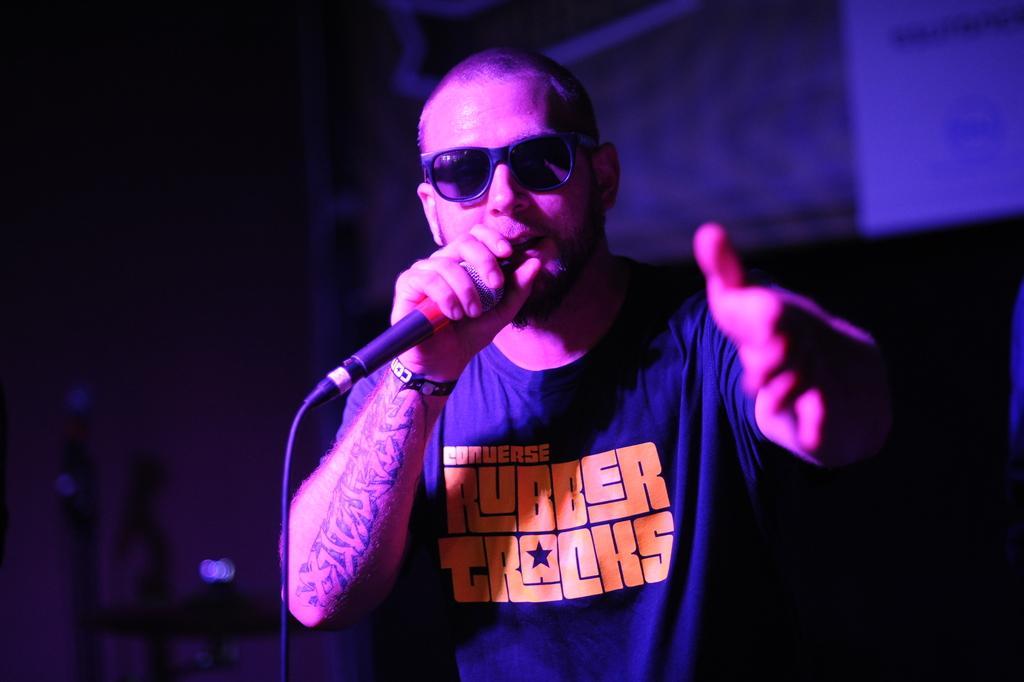Can you describe this image briefly? In this image in the front there is a man holding a mic in his hand and singing and the background is blurry. 